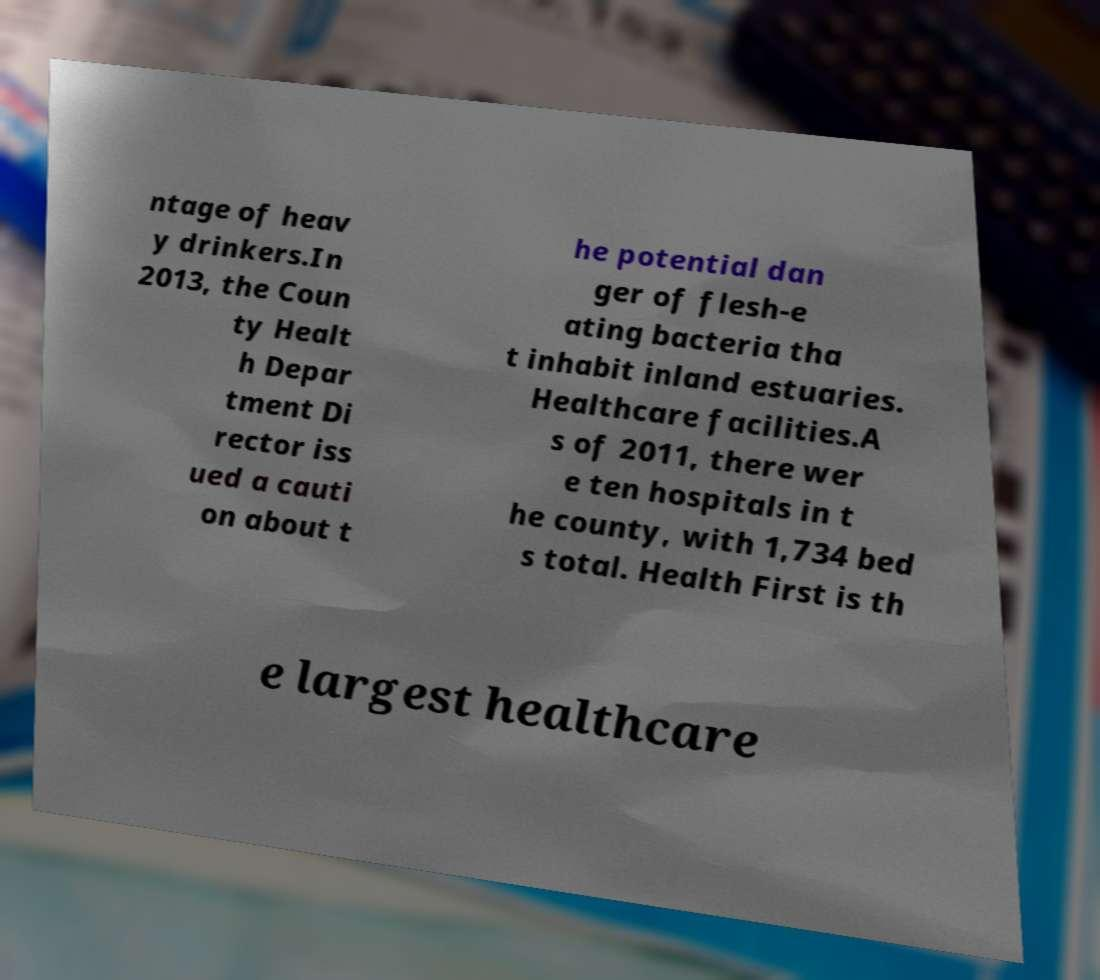Can you accurately transcribe the text from the provided image for me? ntage of heav y drinkers.In 2013, the Coun ty Healt h Depar tment Di rector iss ued a cauti on about t he potential dan ger of flesh-e ating bacteria tha t inhabit inland estuaries. Healthcare facilities.A s of 2011, there wer e ten hospitals in t he county, with 1,734 bed s total. Health First is th e largest healthcare 